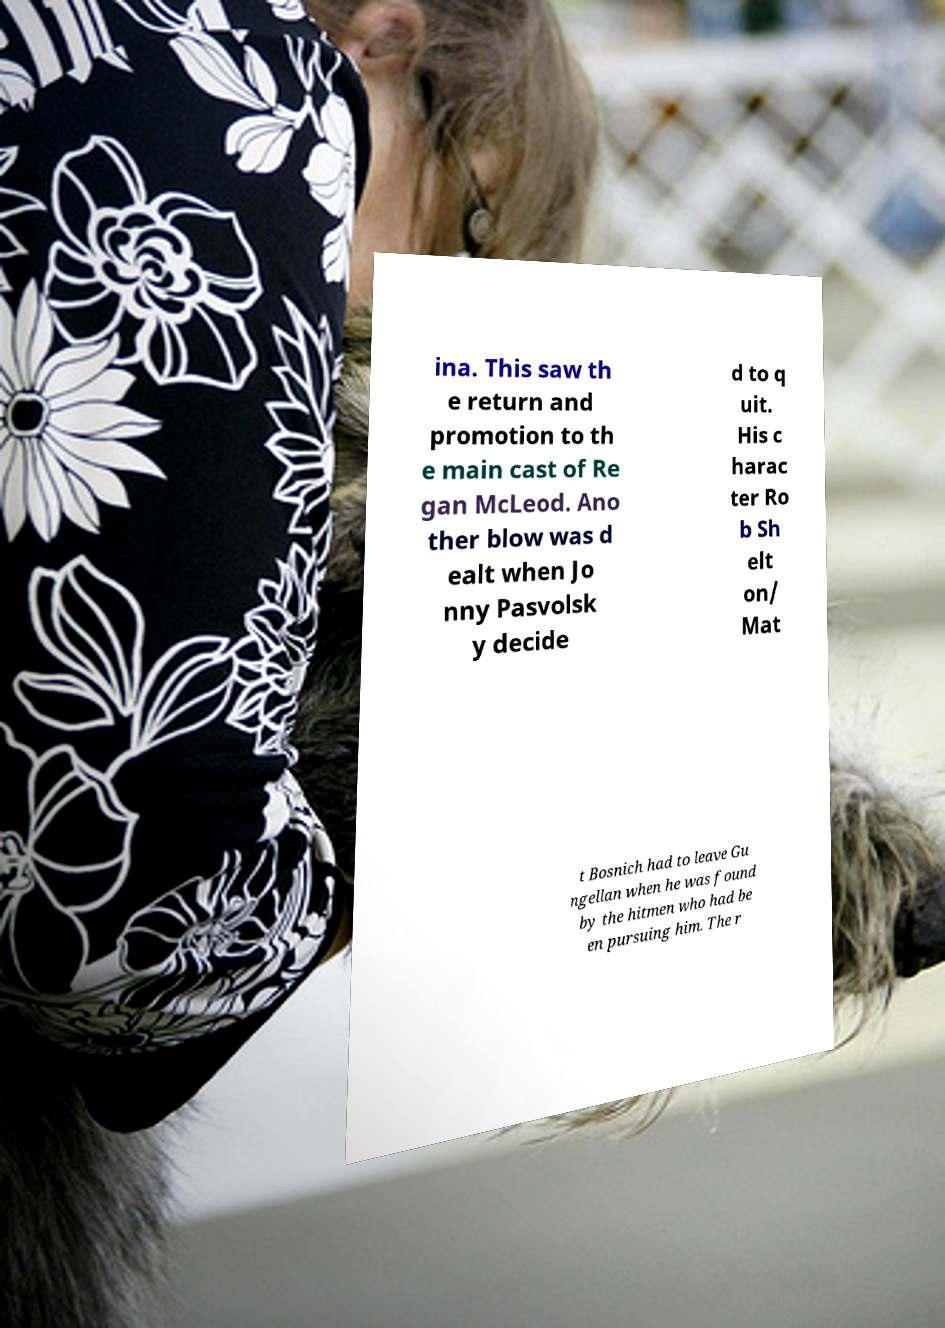I need the written content from this picture converted into text. Can you do that? ina. This saw th e return and promotion to th e main cast of Re gan McLeod. Ano ther blow was d ealt when Jo nny Pasvolsk y decide d to q uit. His c harac ter Ro b Sh elt on/ Mat t Bosnich had to leave Gu ngellan when he was found by the hitmen who had be en pursuing him. The r 